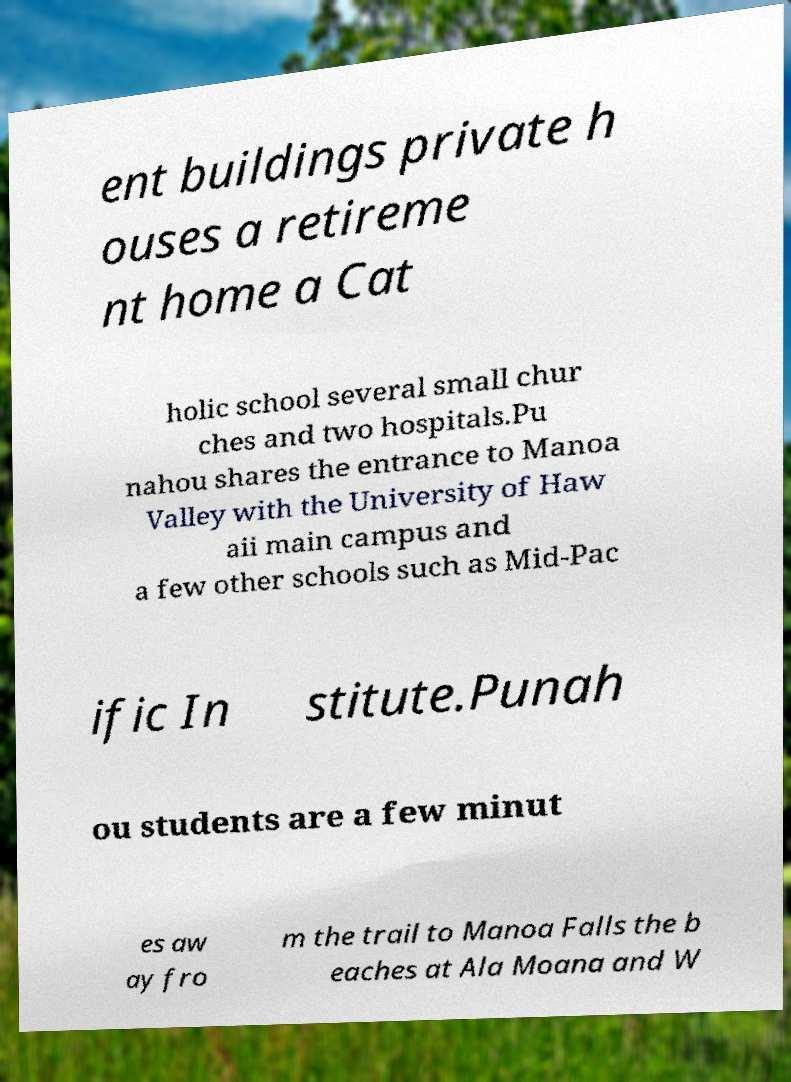Can you accurately transcribe the text from the provided image for me? ent buildings private h ouses a retireme nt home a Cat holic school several small chur ches and two hospitals.Pu nahou shares the entrance to Manoa Valley with the University of Haw aii main campus and a few other schools such as Mid-Pac ific In stitute.Punah ou students are a few minut es aw ay fro m the trail to Manoa Falls the b eaches at Ala Moana and W 